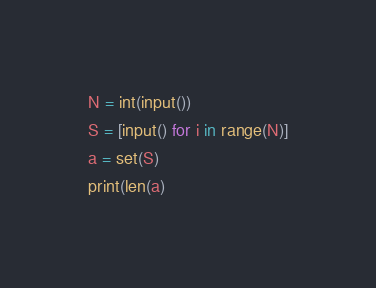<code> <loc_0><loc_0><loc_500><loc_500><_Python_>N = int(input())
S = [input() for i in range(N)]
a = set(S)
print(len(a)</code> 